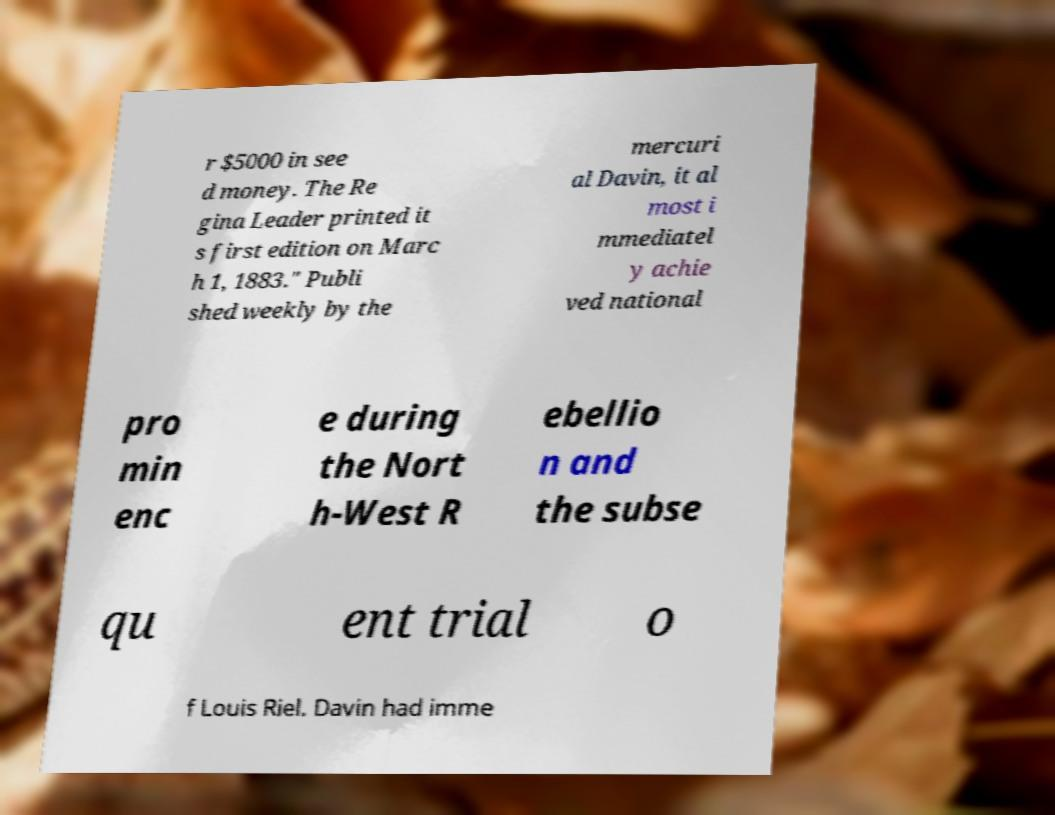Please identify and transcribe the text found in this image. r $5000 in see d money. The Re gina Leader printed it s first edition on Marc h 1, 1883." Publi shed weekly by the mercuri al Davin, it al most i mmediatel y achie ved national pro min enc e during the Nort h-West R ebellio n and the subse qu ent trial o f Louis Riel. Davin had imme 